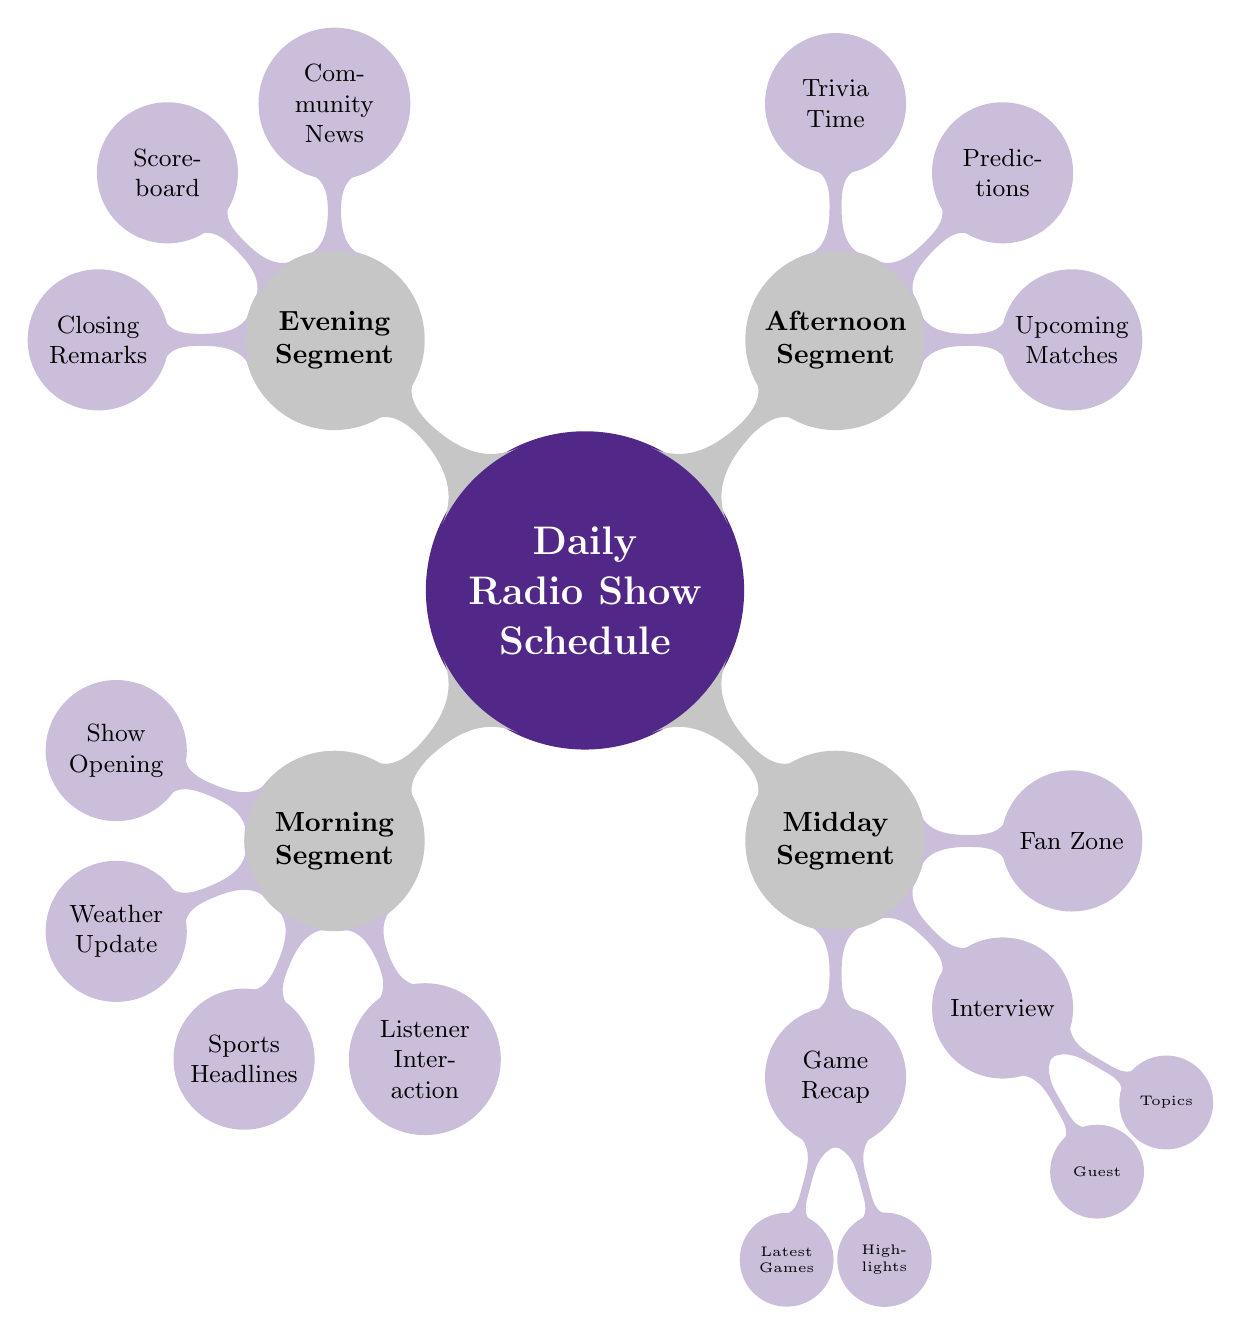What are the four segments of the daily radio show? The daily radio show is divided into four segments: Morning Segment, Midday Segment, Afternoon Segment, and Evening Segment.
Answer: Morning Segment, Midday Segment, Afternoon Segment, Evening Segment What is the main focus of the Afternoon Segment? The Afternoon Segment includes Upcoming Matches, Predictions, and Trivia Time, focusing on future games and listener engagement through trivia.
Answer: Upcoming Matches, Predictions, Trivia Time How many child nodes are under the Midday Segment? The Midday Segment has three main child nodes: Game Recap, Interview, and Fan Zone.
Answer: 3 Which segment includes listener call-ins? Listener Interaction, found in the Morning Segment, involves call-ins from listeners.
Answer: Morning Segment What are the key topics discussed during the Interview in the Midday Segment? The Interview includes a Guest and covers Topics such as strategies, upcoming games, and personal insights from K-State Wildcats coach/player.
Answer: Guest, Topics What is the purpose of the Trivia Time in the Afternoon Segment? Trivia Time is designed as a listener engagement activity that presents sports trivia and challenges to the audience.
Answer: Sports trivia and challenges Which segment provides the latest weather forecast? The Weather Update in the Morning Segment provides the latest weather forecast.
Answer: Morning Segment How many nodes are there in the Evening Segment? The Evening Segment contains three nodes: Community News, Scoreboard, and Closing Remarks.
Answer: 3 